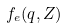<formula> <loc_0><loc_0><loc_500><loc_500>f _ { e } ( q , Z )</formula> 